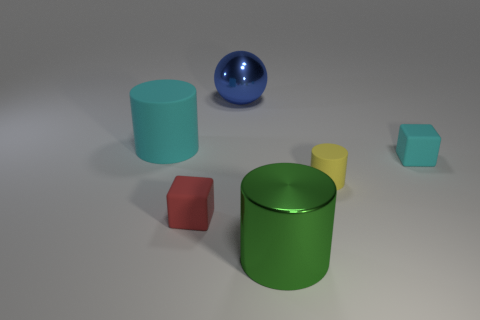What number of large shiny objects have the same color as the metallic sphere?
Ensure brevity in your answer.  0. There is a matte object that is the same size as the blue ball; what is its shape?
Ensure brevity in your answer.  Cylinder. Are there any big green things of the same shape as the large blue object?
Your answer should be very brief. No. How many tiny red things are the same material as the yellow object?
Provide a succinct answer. 1. Are the cube that is on the right side of the tiny rubber cylinder and the small yellow cylinder made of the same material?
Your answer should be very brief. Yes. Are there more cylinders behind the big shiny cylinder than small things on the left side of the red matte block?
Give a very brief answer. Yes. What is the material of the cyan cylinder that is the same size as the ball?
Your answer should be very brief. Rubber. What number of other objects are there of the same material as the blue object?
Ensure brevity in your answer.  1. Does the large thing that is to the right of the large blue metal ball have the same shape as the tiny matte thing that is in front of the yellow rubber thing?
Provide a succinct answer. No. How many other things are the same color as the large metallic cylinder?
Provide a succinct answer. 0. 